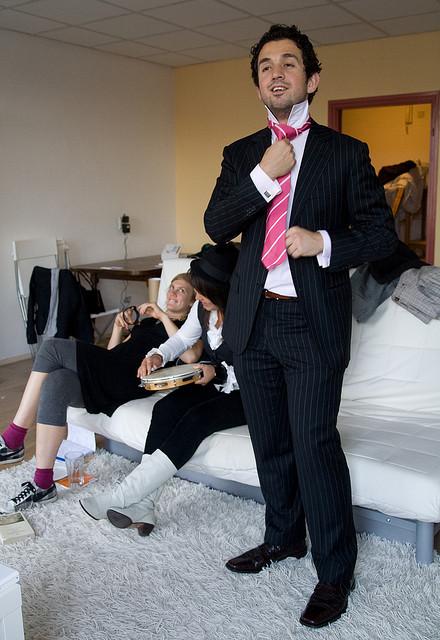Is he wearing a suit?
Concise answer only. Yes. How many people are sitting?
Quick response, please. 2. Does this picture look like a best man?
Short answer required. Yes. 